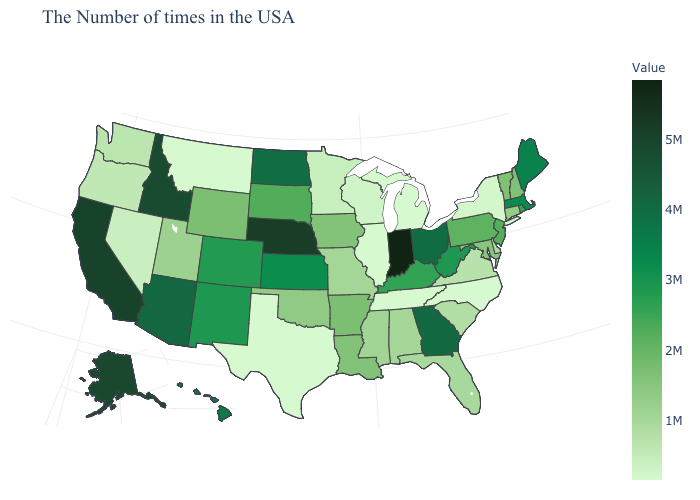Among the states that border New York , does Massachusetts have the highest value?
Keep it brief. Yes. Among the states that border Colorado , does Nebraska have the highest value?
Concise answer only. Yes. Does the map have missing data?
Quick response, please. No. Which states have the lowest value in the MidWest?
Quick response, please. Michigan, Illinois. Which states have the lowest value in the Northeast?
Give a very brief answer. New York. 